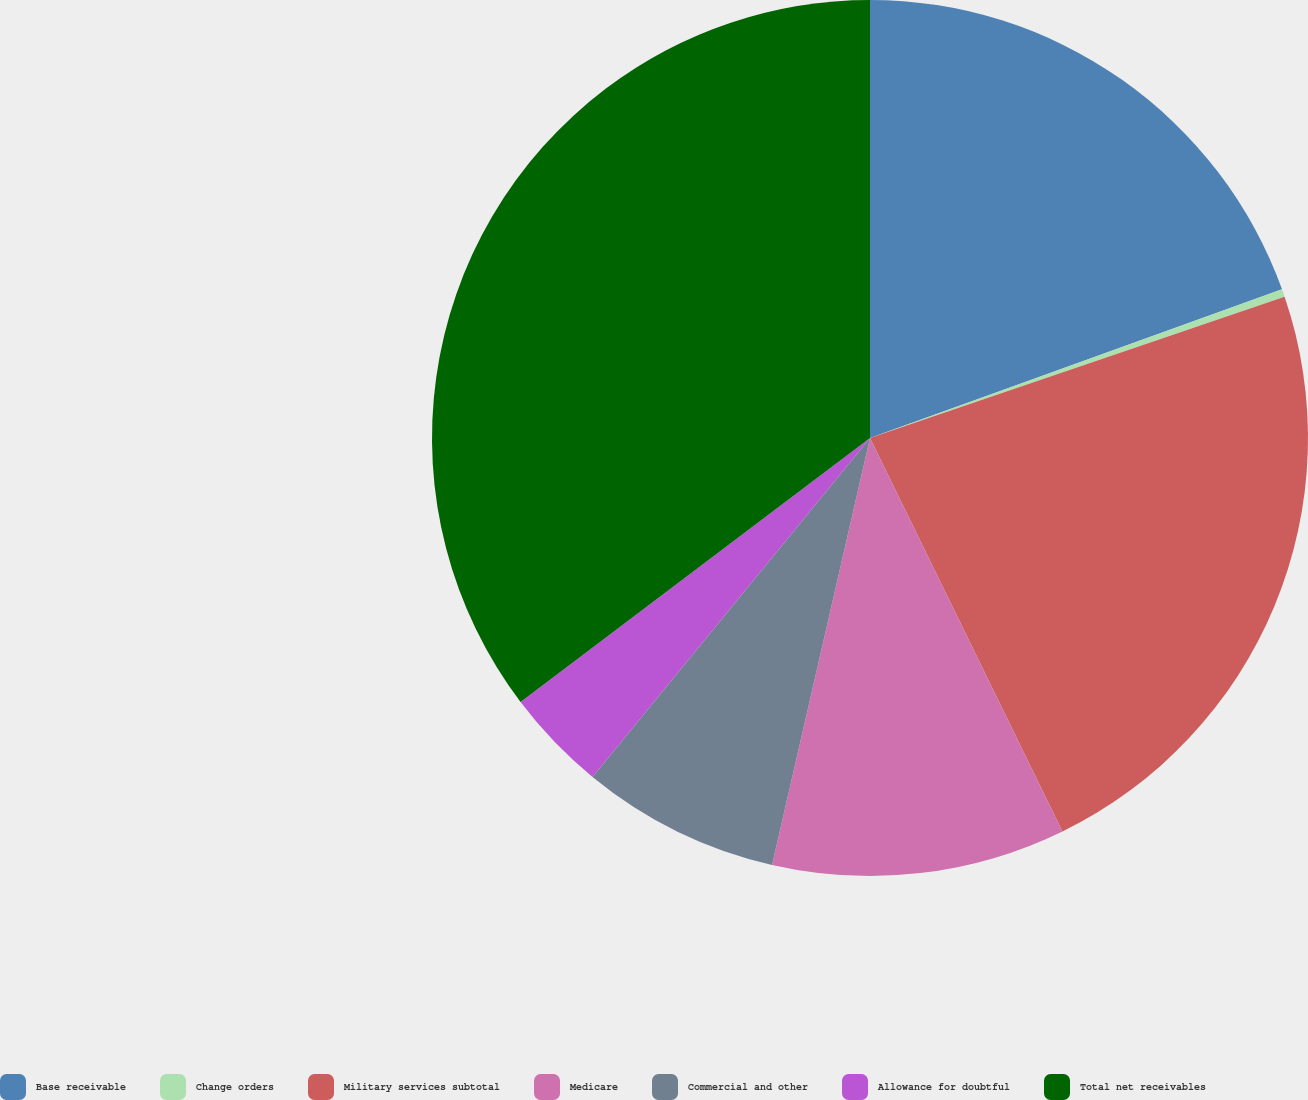Convert chart to OTSL. <chart><loc_0><loc_0><loc_500><loc_500><pie_chart><fcel>Base receivable<fcel>Change orders<fcel>Military services subtotal<fcel>Medicare<fcel>Commercial and other<fcel>Allowance for doubtful<fcel>Total net receivables<nl><fcel>19.49%<fcel>0.28%<fcel>22.99%<fcel>10.83%<fcel>7.33%<fcel>3.78%<fcel>35.3%<nl></chart> 